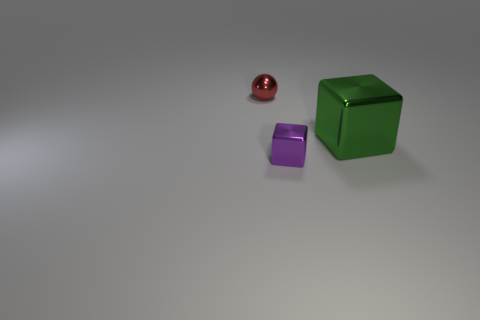What shape is the object that is in front of the metallic block on the right side of the block in front of the green block?
Make the answer very short. Cube. What is the shape of the object that is in front of the small red metal ball and behind the purple shiny block?
Your answer should be very brief. Cube. Is there a red block that has the same material as the big green block?
Your answer should be very brief. No. There is a block that is behind the small purple metal cube; what is its color?
Make the answer very short. Green. Does the red metal object have the same shape as the metal object that is in front of the green metal object?
Ensure brevity in your answer.  No. Is there a big shiny object that has the same color as the large shiny block?
Ensure brevity in your answer.  No. What is the size of the green object that is made of the same material as the purple thing?
Your answer should be compact. Large. Is the color of the big block the same as the small cube?
Provide a succinct answer. No. There is a small metallic object behind the small purple cube; does it have the same shape as the tiny purple metal object?
Your response must be concise. No. What number of other things are the same size as the purple object?
Provide a succinct answer. 1. 